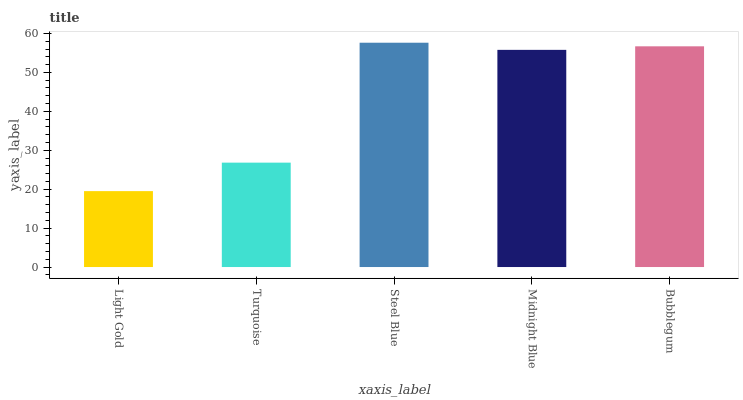Is Light Gold the minimum?
Answer yes or no. Yes. Is Steel Blue the maximum?
Answer yes or no. Yes. Is Turquoise the minimum?
Answer yes or no. No. Is Turquoise the maximum?
Answer yes or no. No. Is Turquoise greater than Light Gold?
Answer yes or no. Yes. Is Light Gold less than Turquoise?
Answer yes or no. Yes. Is Light Gold greater than Turquoise?
Answer yes or no. No. Is Turquoise less than Light Gold?
Answer yes or no. No. Is Midnight Blue the high median?
Answer yes or no. Yes. Is Midnight Blue the low median?
Answer yes or no. Yes. Is Turquoise the high median?
Answer yes or no. No. Is Light Gold the low median?
Answer yes or no. No. 